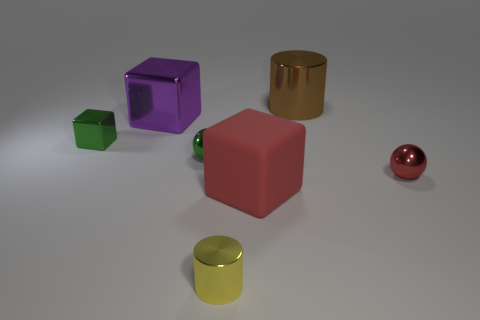Can you describe the lighting in the scene? The lighting in the image comes from above, casting soft shadows directly beneath the objects, which suggests a single, diffused light source, creating a calm and balanced atmosphere. 